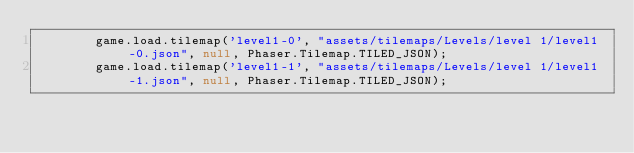<code> <loc_0><loc_0><loc_500><loc_500><_JavaScript_>        game.load.tilemap('level1-0', "assets/tilemaps/Levels/level 1/level1-0.json", null, Phaser.Tilemap.TILED_JSON);
        game.load.tilemap('level1-1', "assets/tilemaps/Levels/level 1/level1-1.json", null, Phaser.Tilemap.TILED_JSON);</code> 